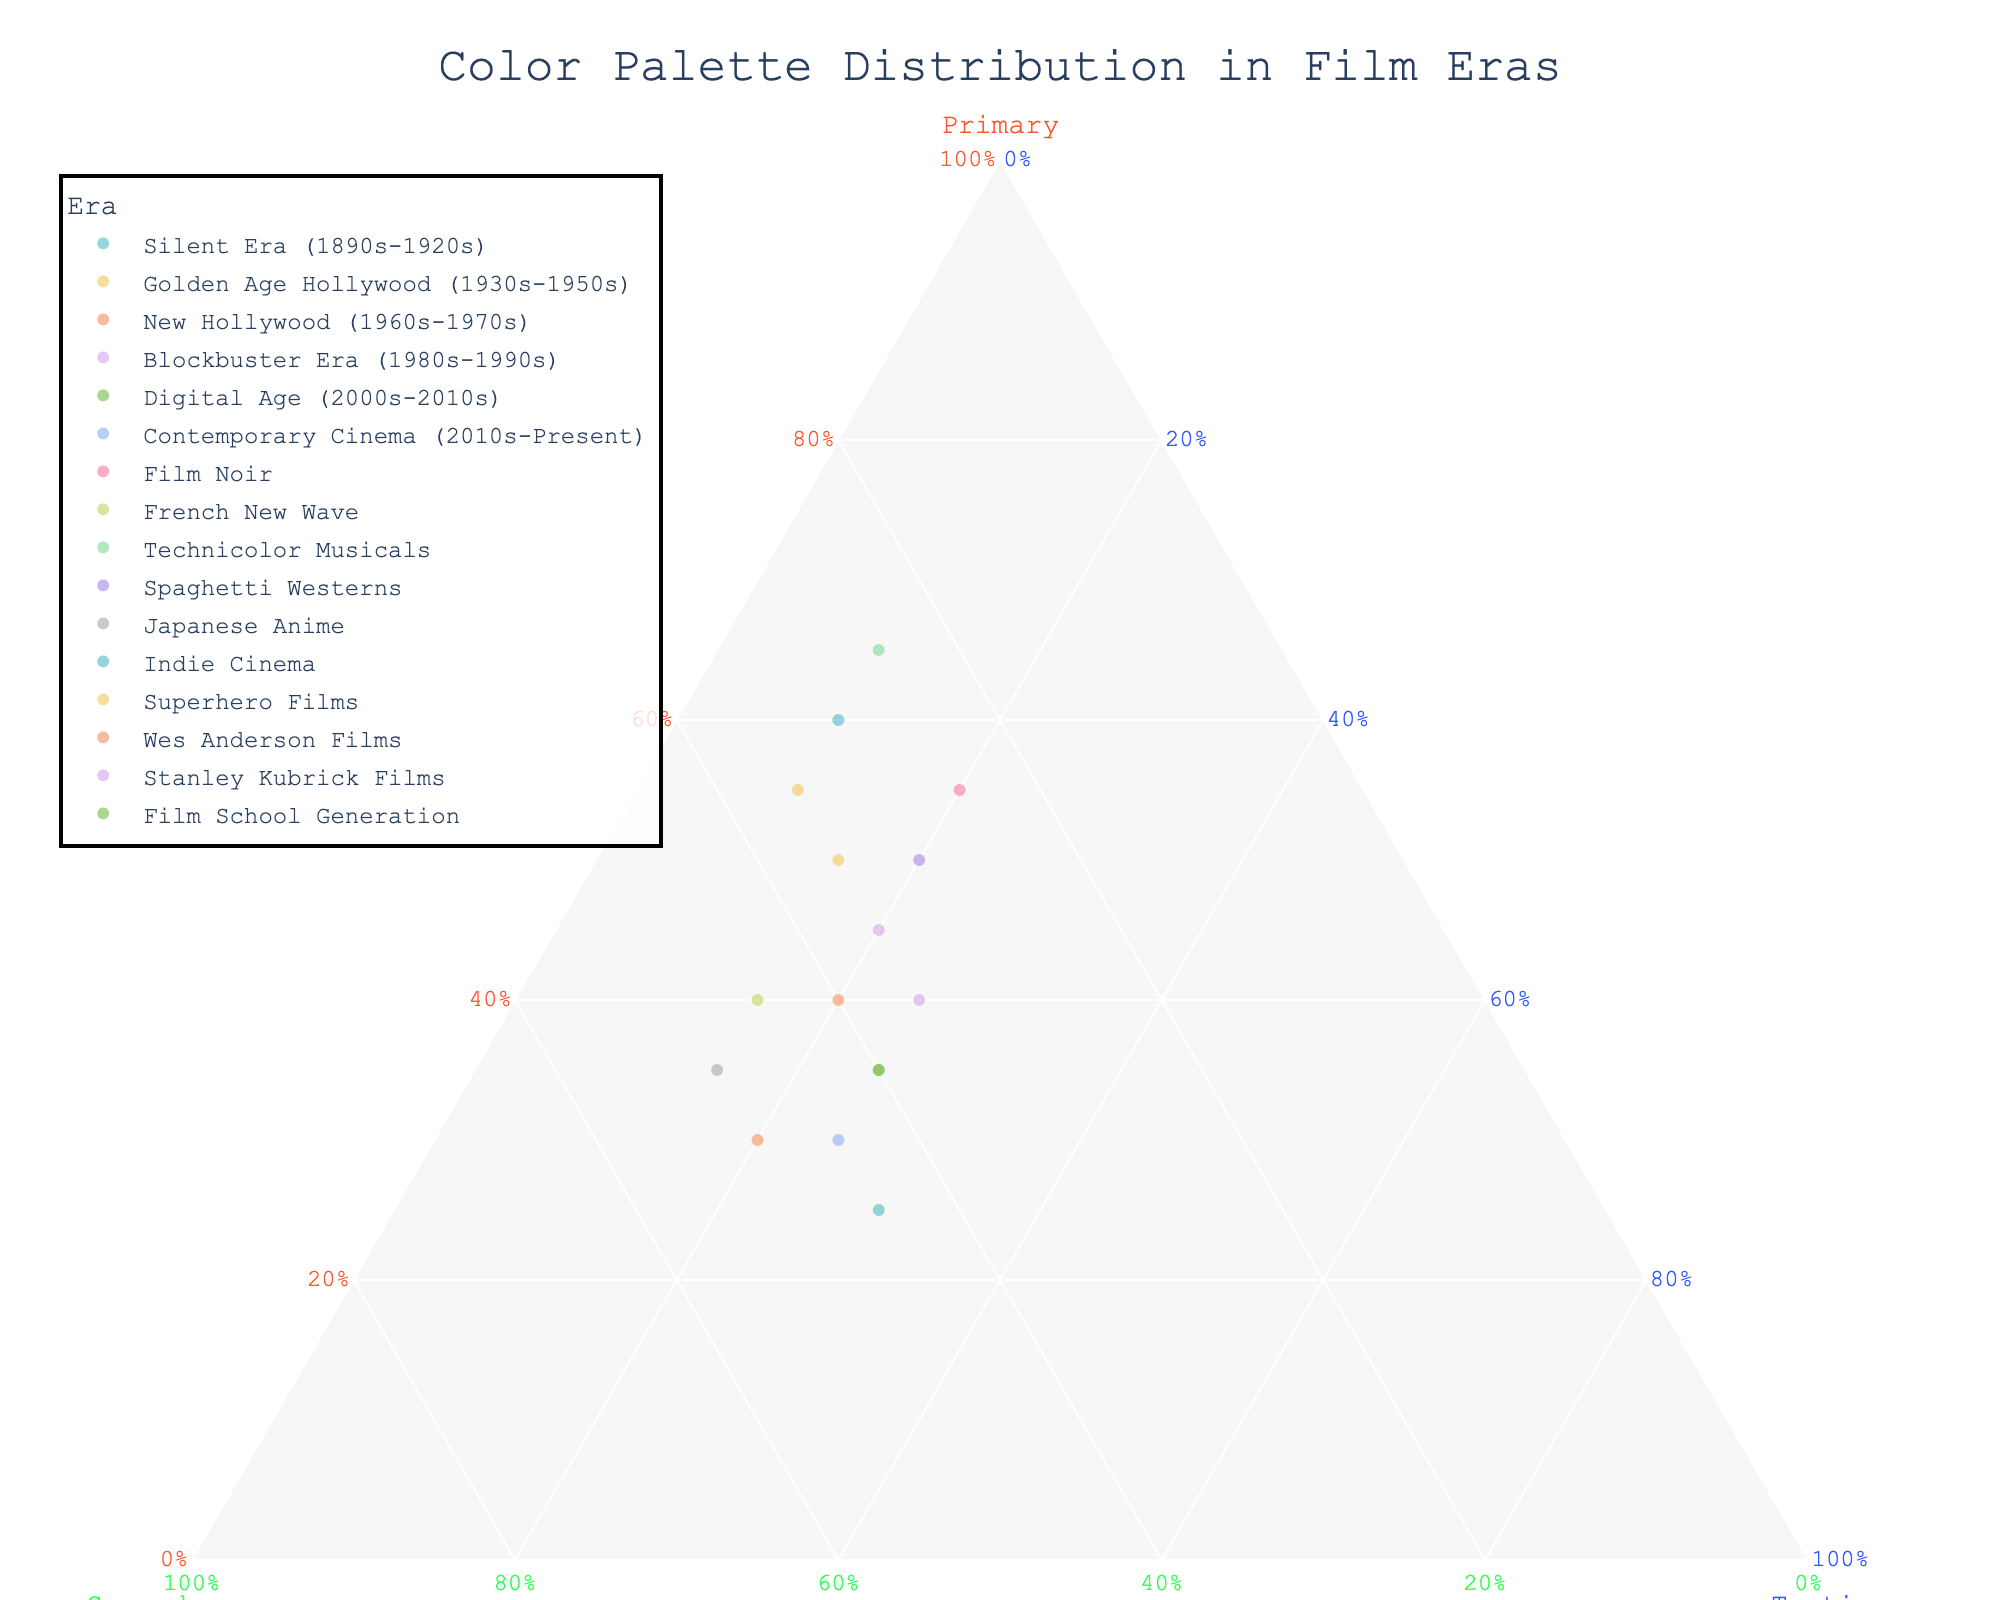How many data points are represented in the ternary plot? Count all the entries in the dataset, each representing a data point in the ternary plot.
Answer: 16 Which era has the highest percentage of primary colors? Observe the data points and identify the one with the highest Primary value: Technicolor Musicals with a Primary percentage of 65%.
Answer: Technicolor Musicals What is the average percentage of secondary colors across all film eras? Sum up all the Secondary percentages and divide by the number of data points:
(30+35+40+35+40+45+25+45+25+30+50+45+35+50+35+40) = 575 / 16
Answer: 35.94% Comparing primary and secondary colors, which color type is more dominant in the Golden Age Hollywood era? For Golden Age Hollywood, compare Primary (50%) and Secondary (35%) values.
Answer: Primary How does the distribution of color palettes in Contemporary Cinema compare to that in Indie Cinema? Compare Primary, Secondary, and Tertiary percentages of Contemporary Cinema (30%, 45%, 25%) and Indie Cinema (25%, 45%, 30%).
Answer: Contemporary Cinema has more Primary and less Tertiary Which type of color dominates the Japanese Anime era? Review the data for Japanese Anime and identify the highest percentage: Secondary (50%).
Answer: Secondary What are the three film eras with the highest percentage of tertiary colors, and what are their values? Identify the three highest Tertiary values and their respective eras: Indie Cinema (30%), Film School Generation (25%), Contemporary Cinema (25%).
Answer: Indie Cinema (30%), Film School Generation (25%), Contemporary Cinema (25%) Is the proportion of secondary colors in the French New Wave higher than that in Spaghetti Westerns? Compare the Secondary percentages: French New Wave (45%) and Spaghetti Westerns (30%).
Answer: Yes How does the primary color distribution in the Blockbuster Era compare to the Digital Age? Compare the Primary percentages of both eras: Blockbuster Era (45%) and Digital Age (35%).
Answer: Blockbuster Era has more Primary What is the trend in the proportion of primary colors from the Silent Era to Contemporary Cinema? Observe the Primary values from the Silent Era (60%) to Contemporary Cinema (30%) and note the decrease over time.
Answer: Decreasing 